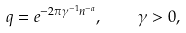<formula> <loc_0><loc_0><loc_500><loc_500>q = e ^ { - 2 \pi \gamma ^ { - 1 } n ^ { - a } } , \quad \gamma > 0 ,</formula> 